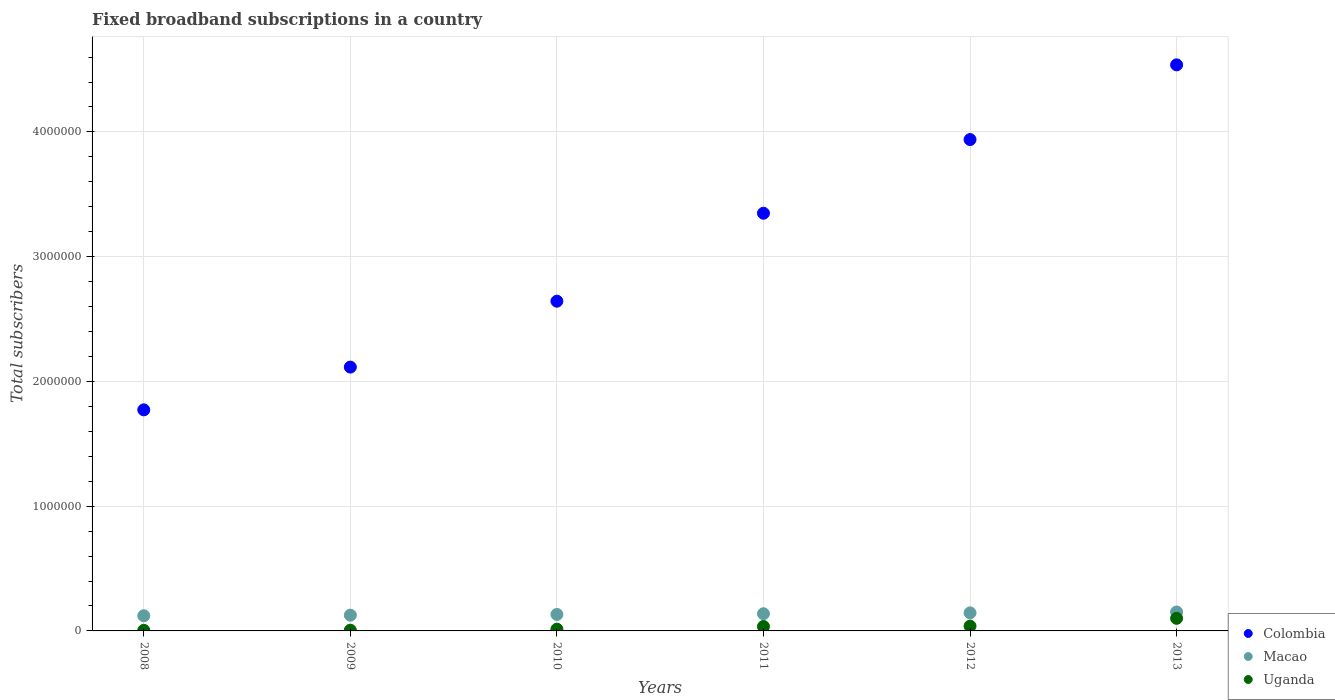How many different coloured dotlines are there?
Make the answer very short. 3. Is the number of dotlines equal to the number of legend labels?
Your response must be concise. Yes. What is the number of broadband subscriptions in Colombia in 2010?
Offer a very short reply. 2.64e+06. Across all years, what is the maximum number of broadband subscriptions in Uganda?
Keep it short and to the point. 1.01e+05. Across all years, what is the minimum number of broadband subscriptions in Colombia?
Make the answer very short. 1.77e+06. In which year was the number of broadband subscriptions in Colombia minimum?
Your answer should be very brief. 2008. What is the total number of broadband subscriptions in Uganda in the graph?
Provide a succinct answer. 2.00e+05. What is the difference between the number of broadband subscriptions in Colombia in 2008 and that in 2009?
Give a very brief answer. -3.43e+05. What is the difference between the number of broadband subscriptions in Macao in 2011 and the number of broadband subscriptions in Uganda in 2009?
Make the answer very short. 1.32e+05. What is the average number of broadband subscriptions in Uganda per year?
Offer a terse response. 3.33e+04. In the year 2013, what is the difference between the number of broadband subscriptions in Uganda and number of broadband subscriptions in Macao?
Make the answer very short. -5.09e+04. In how many years, is the number of broadband subscriptions in Uganda greater than 800000?
Make the answer very short. 0. What is the ratio of the number of broadband subscriptions in Uganda in 2010 to that in 2013?
Make the answer very short. 0.14. Is the number of broadband subscriptions in Macao in 2011 less than that in 2012?
Your response must be concise. Yes. What is the difference between the highest and the second highest number of broadband subscriptions in Uganda?
Your answer should be very brief. 6.25e+04. What is the difference between the highest and the lowest number of broadband subscriptions in Colombia?
Give a very brief answer. 2.77e+06. Is it the case that in every year, the sum of the number of broadband subscriptions in Colombia and number of broadband subscriptions in Uganda  is greater than the number of broadband subscriptions in Macao?
Keep it short and to the point. Yes. Does the number of broadband subscriptions in Macao monotonically increase over the years?
Provide a succinct answer. Yes. Is the number of broadband subscriptions in Colombia strictly greater than the number of broadband subscriptions in Macao over the years?
Give a very brief answer. Yes. Is the number of broadband subscriptions in Uganda strictly less than the number of broadband subscriptions in Macao over the years?
Keep it short and to the point. Yes. How many years are there in the graph?
Ensure brevity in your answer.  6. Where does the legend appear in the graph?
Keep it short and to the point. Bottom right. What is the title of the graph?
Ensure brevity in your answer.  Fixed broadband subscriptions in a country. What is the label or title of the Y-axis?
Your answer should be very brief. Total subscribers. What is the Total subscribers of Colombia in 2008?
Provide a succinct answer. 1.77e+06. What is the Total subscribers of Macao in 2008?
Your response must be concise. 1.22e+05. What is the Total subscribers of Uganda in 2008?
Your response must be concise. 4798. What is the Total subscribers of Colombia in 2009?
Ensure brevity in your answer.  2.11e+06. What is the Total subscribers in Macao in 2009?
Make the answer very short. 1.26e+05. What is the Total subscribers of Uganda in 2009?
Give a very brief answer. 6000. What is the Total subscribers of Colombia in 2010?
Make the answer very short. 2.64e+06. What is the Total subscribers of Macao in 2010?
Give a very brief answer. 1.32e+05. What is the Total subscribers in Uganda in 2010?
Make the answer very short. 1.40e+04. What is the Total subscribers of Colombia in 2011?
Give a very brief answer. 3.35e+06. What is the Total subscribers of Macao in 2011?
Your answer should be compact. 1.38e+05. What is the Total subscribers of Uganda in 2011?
Your answer should be very brief. 3.55e+04. What is the Total subscribers of Colombia in 2012?
Ensure brevity in your answer.  3.94e+06. What is the Total subscribers of Macao in 2012?
Your answer should be compact. 1.45e+05. What is the Total subscribers of Uganda in 2012?
Keep it short and to the point. 3.84e+04. What is the Total subscribers of Colombia in 2013?
Offer a terse response. 4.54e+06. What is the Total subscribers in Macao in 2013?
Your answer should be compact. 1.52e+05. What is the Total subscribers in Uganda in 2013?
Ensure brevity in your answer.  1.01e+05. Across all years, what is the maximum Total subscribers of Colombia?
Offer a very short reply. 4.54e+06. Across all years, what is the maximum Total subscribers in Macao?
Your answer should be very brief. 1.52e+05. Across all years, what is the maximum Total subscribers of Uganda?
Your response must be concise. 1.01e+05. Across all years, what is the minimum Total subscribers in Colombia?
Offer a very short reply. 1.77e+06. Across all years, what is the minimum Total subscribers in Macao?
Your answer should be compact. 1.22e+05. Across all years, what is the minimum Total subscribers of Uganda?
Your answer should be compact. 4798. What is the total Total subscribers in Colombia in the graph?
Provide a short and direct response. 1.84e+07. What is the total Total subscribers of Macao in the graph?
Your answer should be compact. 8.14e+05. What is the total Total subscribers in Uganda in the graph?
Give a very brief answer. 2.00e+05. What is the difference between the Total subscribers of Colombia in 2008 and that in 2009?
Offer a very short reply. -3.43e+05. What is the difference between the Total subscribers in Macao in 2008 and that in 2009?
Ensure brevity in your answer.  -4573. What is the difference between the Total subscribers of Uganda in 2008 and that in 2009?
Offer a terse response. -1202. What is the difference between the Total subscribers of Colombia in 2008 and that in 2010?
Keep it short and to the point. -8.71e+05. What is the difference between the Total subscribers of Macao in 2008 and that in 2010?
Your answer should be compact. -1.05e+04. What is the difference between the Total subscribers in Uganda in 2008 and that in 2010?
Provide a succinct answer. -9202. What is the difference between the Total subscribers of Colombia in 2008 and that in 2011?
Provide a succinct answer. -1.58e+06. What is the difference between the Total subscribers of Macao in 2008 and that in 2011?
Offer a very short reply. -1.61e+04. What is the difference between the Total subscribers of Uganda in 2008 and that in 2011?
Provide a short and direct response. -3.07e+04. What is the difference between the Total subscribers in Colombia in 2008 and that in 2012?
Your answer should be compact. -2.17e+06. What is the difference between the Total subscribers of Macao in 2008 and that in 2012?
Offer a very short reply. -2.30e+04. What is the difference between the Total subscribers of Uganda in 2008 and that in 2012?
Your answer should be compact. -3.36e+04. What is the difference between the Total subscribers of Colombia in 2008 and that in 2013?
Your answer should be compact. -2.77e+06. What is the difference between the Total subscribers of Macao in 2008 and that in 2013?
Ensure brevity in your answer.  -3.02e+04. What is the difference between the Total subscribers in Uganda in 2008 and that in 2013?
Provide a succinct answer. -9.61e+04. What is the difference between the Total subscribers in Colombia in 2009 and that in 2010?
Keep it short and to the point. -5.28e+05. What is the difference between the Total subscribers of Macao in 2009 and that in 2010?
Keep it short and to the point. -5939. What is the difference between the Total subscribers of Uganda in 2009 and that in 2010?
Provide a succinct answer. -8000. What is the difference between the Total subscribers in Colombia in 2009 and that in 2011?
Provide a short and direct response. -1.23e+06. What is the difference between the Total subscribers in Macao in 2009 and that in 2011?
Provide a short and direct response. -1.15e+04. What is the difference between the Total subscribers of Uganda in 2009 and that in 2011?
Provide a short and direct response. -2.95e+04. What is the difference between the Total subscribers in Colombia in 2009 and that in 2012?
Ensure brevity in your answer.  -1.82e+06. What is the difference between the Total subscribers in Macao in 2009 and that in 2012?
Your response must be concise. -1.85e+04. What is the difference between the Total subscribers of Uganda in 2009 and that in 2012?
Give a very brief answer. -3.24e+04. What is the difference between the Total subscribers of Colombia in 2009 and that in 2013?
Provide a succinct answer. -2.42e+06. What is the difference between the Total subscribers of Macao in 2009 and that in 2013?
Offer a very short reply. -2.57e+04. What is the difference between the Total subscribers in Uganda in 2009 and that in 2013?
Ensure brevity in your answer.  -9.49e+04. What is the difference between the Total subscribers of Colombia in 2010 and that in 2011?
Your answer should be very brief. -7.05e+05. What is the difference between the Total subscribers of Macao in 2010 and that in 2011?
Make the answer very short. -5580. What is the difference between the Total subscribers in Uganda in 2010 and that in 2011?
Your answer should be compact. -2.15e+04. What is the difference between the Total subscribers in Colombia in 2010 and that in 2012?
Provide a short and direct response. -1.30e+06. What is the difference between the Total subscribers of Macao in 2010 and that in 2012?
Give a very brief answer. -1.25e+04. What is the difference between the Total subscribers of Uganda in 2010 and that in 2012?
Offer a very short reply. -2.44e+04. What is the difference between the Total subscribers of Colombia in 2010 and that in 2013?
Offer a very short reply. -1.89e+06. What is the difference between the Total subscribers in Macao in 2010 and that in 2013?
Ensure brevity in your answer.  -1.97e+04. What is the difference between the Total subscribers of Uganda in 2010 and that in 2013?
Provide a succinct answer. -8.69e+04. What is the difference between the Total subscribers in Colombia in 2011 and that in 2012?
Your response must be concise. -5.91e+05. What is the difference between the Total subscribers in Macao in 2011 and that in 2012?
Provide a short and direct response. -6935. What is the difference between the Total subscribers of Uganda in 2011 and that in 2012?
Keep it short and to the point. -2886. What is the difference between the Total subscribers in Colombia in 2011 and that in 2013?
Offer a terse response. -1.19e+06. What is the difference between the Total subscribers in Macao in 2011 and that in 2013?
Your response must be concise. -1.41e+04. What is the difference between the Total subscribers of Uganda in 2011 and that in 2013?
Your response must be concise. -6.54e+04. What is the difference between the Total subscribers of Colombia in 2012 and that in 2013?
Offer a very short reply. -5.99e+05. What is the difference between the Total subscribers of Macao in 2012 and that in 2013?
Provide a short and direct response. -7200. What is the difference between the Total subscribers of Uganda in 2012 and that in 2013?
Your answer should be very brief. -6.25e+04. What is the difference between the Total subscribers in Colombia in 2008 and the Total subscribers in Macao in 2009?
Your response must be concise. 1.65e+06. What is the difference between the Total subscribers in Colombia in 2008 and the Total subscribers in Uganda in 2009?
Provide a succinct answer. 1.77e+06. What is the difference between the Total subscribers of Macao in 2008 and the Total subscribers of Uganda in 2009?
Your answer should be compact. 1.16e+05. What is the difference between the Total subscribers of Colombia in 2008 and the Total subscribers of Macao in 2010?
Ensure brevity in your answer.  1.64e+06. What is the difference between the Total subscribers of Colombia in 2008 and the Total subscribers of Uganda in 2010?
Offer a terse response. 1.76e+06. What is the difference between the Total subscribers of Macao in 2008 and the Total subscribers of Uganda in 2010?
Ensure brevity in your answer.  1.08e+05. What is the difference between the Total subscribers in Colombia in 2008 and the Total subscribers in Macao in 2011?
Provide a short and direct response. 1.63e+06. What is the difference between the Total subscribers of Colombia in 2008 and the Total subscribers of Uganda in 2011?
Make the answer very short. 1.74e+06. What is the difference between the Total subscribers of Macao in 2008 and the Total subscribers of Uganda in 2011?
Give a very brief answer. 8.61e+04. What is the difference between the Total subscribers in Colombia in 2008 and the Total subscribers in Macao in 2012?
Your answer should be compact. 1.63e+06. What is the difference between the Total subscribers of Colombia in 2008 and the Total subscribers of Uganda in 2012?
Give a very brief answer. 1.73e+06. What is the difference between the Total subscribers of Macao in 2008 and the Total subscribers of Uganda in 2012?
Ensure brevity in your answer.  8.32e+04. What is the difference between the Total subscribers in Colombia in 2008 and the Total subscribers in Macao in 2013?
Ensure brevity in your answer.  1.62e+06. What is the difference between the Total subscribers in Colombia in 2008 and the Total subscribers in Uganda in 2013?
Give a very brief answer. 1.67e+06. What is the difference between the Total subscribers in Macao in 2008 and the Total subscribers in Uganda in 2013?
Your answer should be very brief. 2.07e+04. What is the difference between the Total subscribers of Colombia in 2009 and the Total subscribers of Macao in 2010?
Keep it short and to the point. 1.98e+06. What is the difference between the Total subscribers in Colombia in 2009 and the Total subscribers in Uganda in 2010?
Give a very brief answer. 2.10e+06. What is the difference between the Total subscribers of Macao in 2009 and the Total subscribers of Uganda in 2010?
Ensure brevity in your answer.  1.12e+05. What is the difference between the Total subscribers of Colombia in 2009 and the Total subscribers of Macao in 2011?
Offer a terse response. 1.98e+06. What is the difference between the Total subscribers of Colombia in 2009 and the Total subscribers of Uganda in 2011?
Keep it short and to the point. 2.08e+06. What is the difference between the Total subscribers in Macao in 2009 and the Total subscribers in Uganda in 2011?
Your response must be concise. 9.06e+04. What is the difference between the Total subscribers of Colombia in 2009 and the Total subscribers of Macao in 2012?
Offer a terse response. 1.97e+06. What is the difference between the Total subscribers of Colombia in 2009 and the Total subscribers of Uganda in 2012?
Make the answer very short. 2.08e+06. What is the difference between the Total subscribers in Macao in 2009 and the Total subscribers in Uganda in 2012?
Ensure brevity in your answer.  8.77e+04. What is the difference between the Total subscribers of Colombia in 2009 and the Total subscribers of Macao in 2013?
Your response must be concise. 1.96e+06. What is the difference between the Total subscribers in Colombia in 2009 and the Total subscribers in Uganda in 2013?
Provide a succinct answer. 2.01e+06. What is the difference between the Total subscribers of Macao in 2009 and the Total subscribers of Uganda in 2013?
Provide a succinct answer. 2.52e+04. What is the difference between the Total subscribers in Colombia in 2010 and the Total subscribers in Macao in 2011?
Keep it short and to the point. 2.51e+06. What is the difference between the Total subscribers of Colombia in 2010 and the Total subscribers of Uganda in 2011?
Give a very brief answer. 2.61e+06. What is the difference between the Total subscribers of Macao in 2010 and the Total subscribers of Uganda in 2011?
Offer a very short reply. 9.66e+04. What is the difference between the Total subscribers of Colombia in 2010 and the Total subscribers of Macao in 2012?
Give a very brief answer. 2.50e+06. What is the difference between the Total subscribers of Colombia in 2010 and the Total subscribers of Uganda in 2012?
Provide a short and direct response. 2.60e+06. What is the difference between the Total subscribers in Macao in 2010 and the Total subscribers in Uganda in 2012?
Offer a very short reply. 9.37e+04. What is the difference between the Total subscribers of Colombia in 2010 and the Total subscribers of Macao in 2013?
Ensure brevity in your answer.  2.49e+06. What is the difference between the Total subscribers of Colombia in 2010 and the Total subscribers of Uganda in 2013?
Your answer should be very brief. 2.54e+06. What is the difference between the Total subscribers in Macao in 2010 and the Total subscribers in Uganda in 2013?
Offer a terse response. 3.12e+04. What is the difference between the Total subscribers of Colombia in 2011 and the Total subscribers of Macao in 2012?
Provide a succinct answer. 3.20e+06. What is the difference between the Total subscribers of Colombia in 2011 and the Total subscribers of Uganda in 2012?
Make the answer very short. 3.31e+06. What is the difference between the Total subscribers in Macao in 2011 and the Total subscribers in Uganda in 2012?
Your answer should be very brief. 9.93e+04. What is the difference between the Total subscribers in Colombia in 2011 and the Total subscribers in Macao in 2013?
Ensure brevity in your answer.  3.20e+06. What is the difference between the Total subscribers in Colombia in 2011 and the Total subscribers in Uganda in 2013?
Provide a short and direct response. 3.25e+06. What is the difference between the Total subscribers in Macao in 2011 and the Total subscribers in Uganda in 2013?
Ensure brevity in your answer.  3.68e+04. What is the difference between the Total subscribers of Colombia in 2012 and the Total subscribers of Macao in 2013?
Ensure brevity in your answer.  3.79e+06. What is the difference between the Total subscribers of Colombia in 2012 and the Total subscribers of Uganda in 2013?
Your answer should be very brief. 3.84e+06. What is the difference between the Total subscribers of Macao in 2012 and the Total subscribers of Uganda in 2013?
Provide a short and direct response. 4.37e+04. What is the average Total subscribers in Colombia per year?
Offer a terse response. 3.06e+06. What is the average Total subscribers of Macao per year?
Offer a terse response. 1.36e+05. What is the average Total subscribers in Uganda per year?
Offer a terse response. 3.33e+04. In the year 2008, what is the difference between the Total subscribers in Colombia and Total subscribers in Macao?
Provide a succinct answer. 1.65e+06. In the year 2008, what is the difference between the Total subscribers in Colombia and Total subscribers in Uganda?
Ensure brevity in your answer.  1.77e+06. In the year 2008, what is the difference between the Total subscribers of Macao and Total subscribers of Uganda?
Make the answer very short. 1.17e+05. In the year 2009, what is the difference between the Total subscribers in Colombia and Total subscribers in Macao?
Your answer should be compact. 1.99e+06. In the year 2009, what is the difference between the Total subscribers in Colombia and Total subscribers in Uganda?
Give a very brief answer. 2.11e+06. In the year 2009, what is the difference between the Total subscribers of Macao and Total subscribers of Uganda?
Your response must be concise. 1.20e+05. In the year 2010, what is the difference between the Total subscribers in Colombia and Total subscribers in Macao?
Keep it short and to the point. 2.51e+06. In the year 2010, what is the difference between the Total subscribers in Colombia and Total subscribers in Uganda?
Your answer should be very brief. 2.63e+06. In the year 2010, what is the difference between the Total subscribers in Macao and Total subscribers in Uganda?
Your response must be concise. 1.18e+05. In the year 2011, what is the difference between the Total subscribers in Colombia and Total subscribers in Macao?
Keep it short and to the point. 3.21e+06. In the year 2011, what is the difference between the Total subscribers of Colombia and Total subscribers of Uganda?
Provide a short and direct response. 3.31e+06. In the year 2011, what is the difference between the Total subscribers of Macao and Total subscribers of Uganda?
Keep it short and to the point. 1.02e+05. In the year 2012, what is the difference between the Total subscribers of Colombia and Total subscribers of Macao?
Your answer should be very brief. 3.79e+06. In the year 2012, what is the difference between the Total subscribers in Colombia and Total subscribers in Uganda?
Keep it short and to the point. 3.90e+06. In the year 2012, what is the difference between the Total subscribers of Macao and Total subscribers of Uganda?
Give a very brief answer. 1.06e+05. In the year 2013, what is the difference between the Total subscribers in Colombia and Total subscribers in Macao?
Offer a very short reply. 4.39e+06. In the year 2013, what is the difference between the Total subscribers in Colombia and Total subscribers in Uganda?
Provide a short and direct response. 4.44e+06. In the year 2013, what is the difference between the Total subscribers of Macao and Total subscribers of Uganda?
Your answer should be very brief. 5.09e+04. What is the ratio of the Total subscribers of Colombia in 2008 to that in 2009?
Offer a very short reply. 0.84. What is the ratio of the Total subscribers of Macao in 2008 to that in 2009?
Offer a very short reply. 0.96. What is the ratio of the Total subscribers of Uganda in 2008 to that in 2009?
Offer a very short reply. 0.8. What is the ratio of the Total subscribers of Colombia in 2008 to that in 2010?
Ensure brevity in your answer.  0.67. What is the ratio of the Total subscribers in Macao in 2008 to that in 2010?
Offer a terse response. 0.92. What is the ratio of the Total subscribers of Uganda in 2008 to that in 2010?
Give a very brief answer. 0.34. What is the ratio of the Total subscribers of Colombia in 2008 to that in 2011?
Provide a succinct answer. 0.53. What is the ratio of the Total subscribers in Macao in 2008 to that in 2011?
Provide a succinct answer. 0.88. What is the ratio of the Total subscribers of Uganda in 2008 to that in 2011?
Give a very brief answer. 0.14. What is the ratio of the Total subscribers of Colombia in 2008 to that in 2012?
Offer a terse response. 0.45. What is the ratio of the Total subscribers of Macao in 2008 to that in 2012?
Offer a very short reply. 0.84. What is the ratio of the Total subscribers of Uganda in 2008 to that in 2012?
Your response must be concise. 0.12. What is the ratio of the Total subscribers of Colombia in 2008 to that in 2013?
Keep it short and to the point. 0.39. What is the ratio of the Total subscribers in Macao in 2008 to that in 2013?
Keep it short and to the point. 0.8. What is the ratio of the Total subscribers in Uganda in 2008 to that in 2013?
Give a very brief answer. 0.05. What is the ratio of the Total subscribers in Colombia in 2009 to that in 2010?
Your answer should be compact. 0.8. What is the ratio of the Total subscribers of Macao in 2009 to that in 2010?
Your response must be concise. 0.95. What is the ratio of the Total subscribers in Uganda in 2009 to that in 2010?
Ensure brevity in your answer.  0.43. What is the ratio of the Total subscribers in Colombia in 2009 to that in 2011?
Provide a short and direct response. 0.63. What is the ratio of the Total subscribers in Macao in 2009 to that in 2011?
Give a very brief answer. 0.92. What is the ratio of the Total subscribers in Uganda in 2009 to that in 2011?
Offer a very short reply. 0.17. What is the ratio of the Total subscribers in Colombia in 2009 to that in 2012?
Provide a short and direct response. 0.54. What is the ratio of the Total subscribers in Macao in 2009 to that in 2012?
Your answer should be compact. 0.87. What is the ratio of the Total subscribers of Uganda in 2009 to that in 2012?
Offer a very short reply. 0.16. What is the ratio of the Total subscribers in Colombia in 2009 to that in 2013?
Ensure brevity in your answer.  0.47. What is the ratio of the Total subscribers of Macao in 2009 to that in 2013?
Keep it short and to the point. 0.83. What is the ratio of the Total subscribers in Uganda in 2009 to that in 2013?
Provide a succinct answer. 0.06. What is the ratio of the Total subscribers in Colombia in 2010 to that in 2011?
Provide a short and direct response. 0.79. What is the ratio of the Total subscribers of Macao in 2010 to that in 2011?
Your answer should be compact. 0.96. What is the ratio of the Total subscribers in Uganda in 2010 to that in 2011?
Keep it short and to the point. 0.39. What is the ratio of the Total subscribers in Colombia in 2010 to that in 2012?
Your response must be concise. 0.67. What is the ratio of the Total subscribers of Macao in 2010 to that in 2012?
Your answer should be compact. 0.91. What is the ratio of the Total subscribers in Uganda in 2010 to that in 2012?
Ensure brevity in your answer.  0.36. What is the ratio of the Total subscribers in Colombia in 2010 to that in 2013?
Give a very brief answer. 0.58. What is the ratio of the Total subscribers in Macao in 2010 to that in 2013?
Your answer should be very brief. 0.87. What is the ratio of the Total subscribers of Uganda in 2010 to that in 2013?
Offer a very short reply. 0.14. What is the ratio of the Total subscribers in Colombia in 2011 to that in 2012?
Your response must be concise. 0.85. What is the ratio of the Total subscribers in Uganda in 2011 to that in 2012?
Make the answer very short. 0.92. What is the ratio of the Total subscribers in Colombia in 2011 to that in 2013?
Your answer should be compact. 0.74. What is the ratio of the Total subscribers in Macao in 2011 to that in 2013?
Keep it short and to the point. 0.91. What is the ratio of the Total subscribers in Uganda in 2011 to that in 2013?
Keep it short and to the point. 0.35. What is the ratio of the Total subscribers in Colombia in 2012 to that in 2013?
Keep it short and to the point. 0.87. What is the ratio of the Total subscribers of Macao in 2012 to that in 2013?
Your answer should be compact. 0.95. What is the ratio of the Total subscribers of Uganda in 2012 to that in 2013?
Give a very brief answer. 0.38. What is the difference between the highest and the second highest Total subscribers in Colombia?
Your response must be concise. 5.99e+05. What is the difference between the highest and the second highest Total subscribers of Macao?
Your answer should be compact. 7200. What is the difference between the highest and the second highest Total subscribers of Uganda?
Offer a very short reply. 6.25e+04. What is the difference between the highest and the lowest Total subscribers of Colombia?
Offer a terse response. 2.77e+06. What is the difference between the highest and the lowest Total subscribers of Macao?
Offer a terse response. 3.02e+04. What is the difference between the highest and the lowest Total subscribers in Uganda?
Keep it short and to the point. 9.61e+04. 